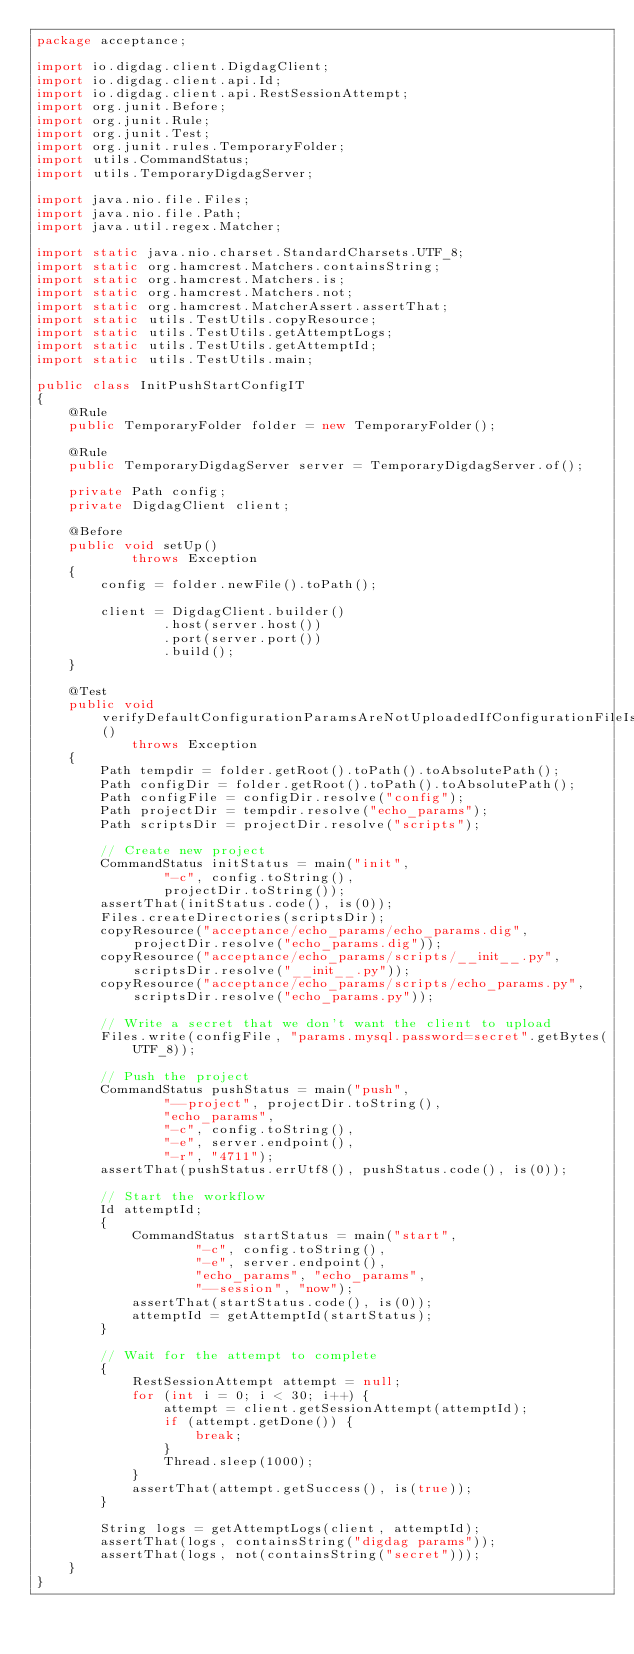<code> <loc_0><loc_0><loc_500><loc_500><_Java_>package acceptance;

import io.digdag.client.DigdagClient;
import io.digdag.client.api.Id;
import io.digdag.client.api.RestSessionAttempt;
import org.junit.Before;
import org.junit.Rule;
import org.junit.Test;
import org.junit.rules.TemporaryFolder;
import utils.CommandStatus;
import utils.TemporaryDigdagServer;

import java.nio.file.Files;
import java.nio.file.Path;
import java.util.regex.Matcher;

import static java.nio.charset.StandardCharsets.UTF_8;
import static org.hamcrest.Matchers.containsString;
import static org.hamcrest.Matchers.is;
import static org.hamcrest.Matchers.not;
import static org.hamcrest.MatcherAssert.assertThat;
import static utils.TestUtils.copyResource;
import static utils.TestUtils.getAttemptLogs;
import static utils.TestUtils.getAttemptId;
import static utils.TestUtils.main;

public class InitPushStartConfigIT
{
    @Rule
    public TemporaryFolder folder = new TemporaryFolder();

    @Rule
    public TemporaryDigdagServer server = TemporaryDigdagServer.of();

    private Path config;
    private DigdagClient client;

    @Before
    public void setUp()
            throws Exception
    {
        config = folder.newFile().toPath();

        client = DigdagClient.builder()
                .host(server.host())
                .port(server.port())
                .build();
    }

    @Test
    public void verifyDefaultConfigurationParamsAreNotUploadedIfConfigurationFileIsSpecified()
            throws Exception
    {
        Path tempdir = folder.getRoot().toPath().toAbsolutePath();
        Path configDir = folder.getRoot().toPath().toAbsolutePath();
        Path configFile = configDir.resolve("config");
        Path projectDir = tempdir.resolve("echo_params");
        Path scriptsDir = projectDir.resolve("scripts");

        // Create new project
        CommandStatus initStatus = main("init",
                "-c", config.toString(),
                projectDir.toString());
        assertThat(initStatus.code(), is(0));
        Files.createDirectories(scriptsDir);
        copyResource("acceptance/echo_params/echo_params.dig", projectDir.resolve("echo_params.dig"));
        copyResource("acceptance/echo_params/scripts/__init__.py", scriptsDir.resolve("__init__.py"));
        copyResource("acceptance/echo_params/scripts/echo_params.py", scriptsDir.resolve("echo_params.py"));

        // Write a secret that we don't want the client to upload
        Files.write(configFile, "params.mysql.password=secret".getBytes(UTF_8));

        // Push the project
        CommandStatus pushStatus = main("push",
                "--project", projectDir.toString(),
                "echo_params",
                "-c", config.toString(),
                "-e", server.endpoint(),
                "-r", "4711");
        assertThat(pushStatus.errUtf8(), pushStatus.code(), is(0));

        // Start the workflow
        Id attemptId;
        {
            CommandStatus startStatus = main("start",
                    "-c", config.toString(),
                    "-e", server.endpoint(),
                    "echo_params", "echo_params",
                    "--session", "now");
            assertThat(startStatus.code(), is(0));
            attemptId = getAttemptId(startStatus);
        }

        // Wait for the attempt to complete
        {
            RestSessionAttempt attempt = null;
            for (int i = 0; i < 30; i++) {
                attempt = client.getSessionAttempt(attemptId);
                if (attempt.getDone()) {
                    break;
                }
                Thread.sleep(1000);
            }
            assertThat(attempt.getSuccess(), is(true));
        }

        String logs = getAttemptLogs(client, attemptId);
        assertThat(logs, containsString("digdag params"));
        assertThat(logs, not(containsString("secret")));
    }
}
</code> 